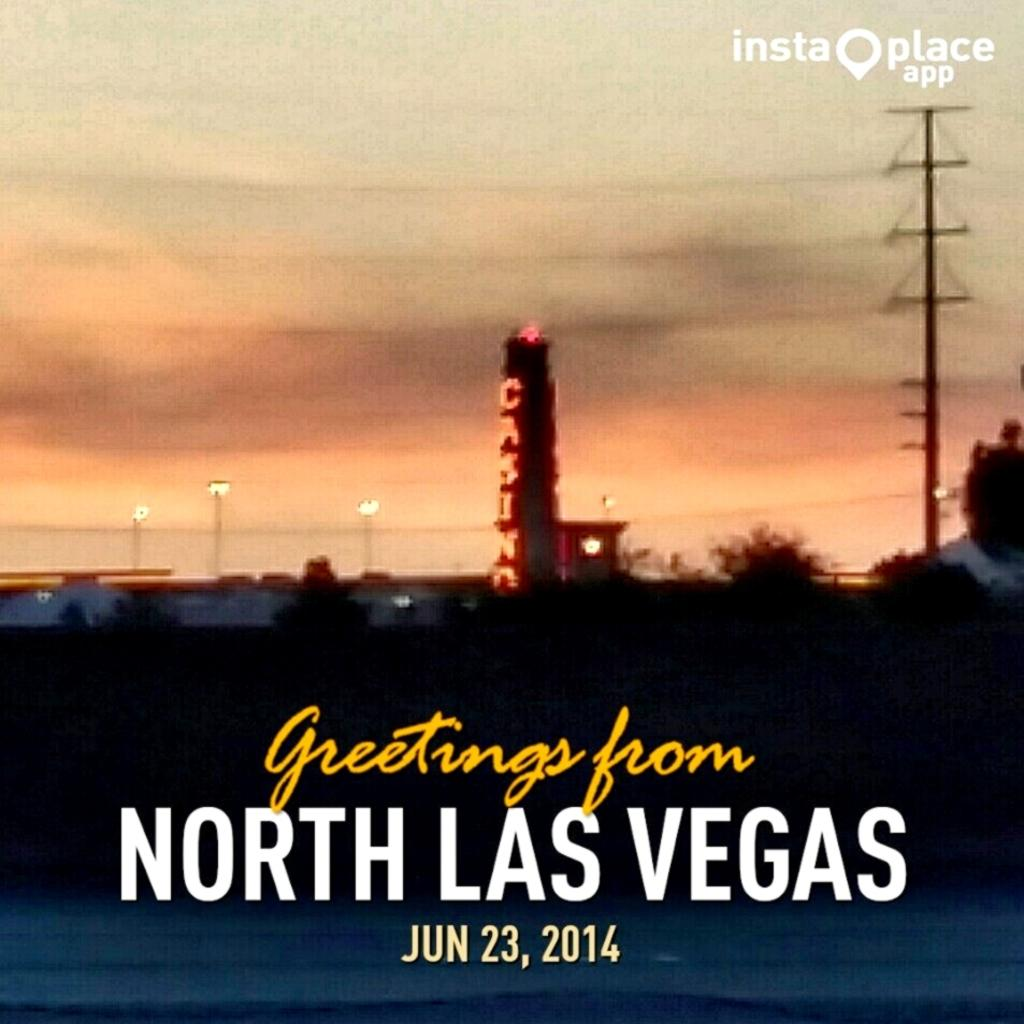<image>
Write a terse but informative summary of the picture. A picture of North Las Vegas includes a casino. 